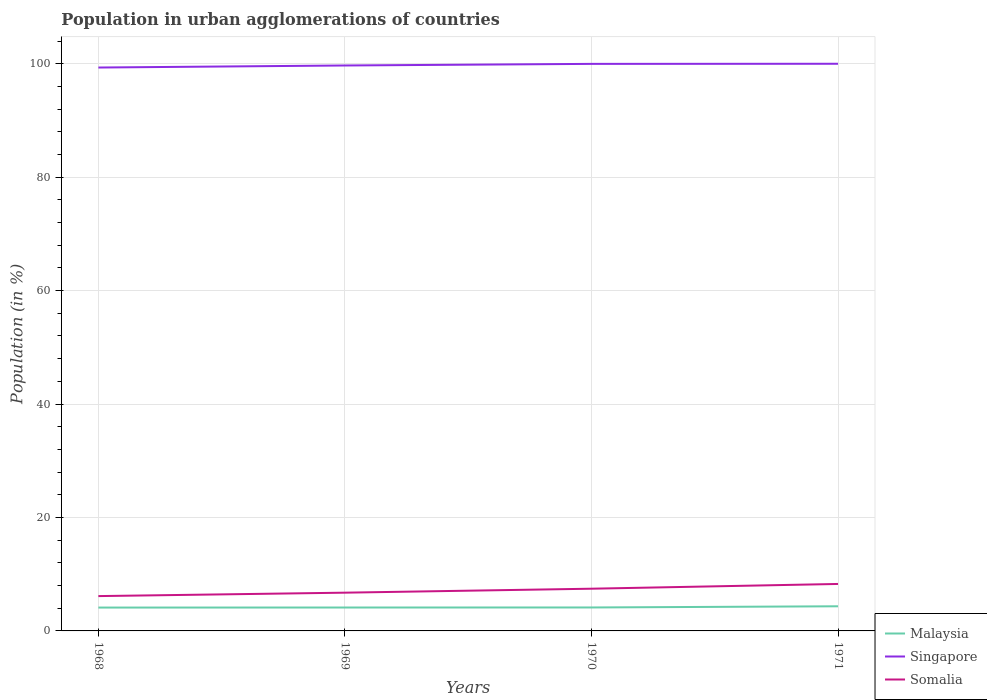How many different coloured lines are there?
Your response must be concise. 3. Across all years, what is the maximum percentage of population in urban agglomerations in Malaysia?
Give a very brief answer. 4.12. In which year was the percentage of population in urban agglomerations in Somalia maximum?
Offer a terse response. 1968. What is the total percentage of population in urban agglomerations in Somalia in the graph?
Offer a terse response. -0.84. What is the difference between the highest and the second highest percentage of population in urban agglomerations in Malaysia?
Your answer should be very brief. 0.23. What is the difference between the highest and the lowest percentage of population in urban agglomerations in Singapore?
Offer a very short reply. 2. How many lines are there?
Keep it short and to the point. 3. How many years are there in the graph?
Make the answer very short. 4. Are the values on the major ticks of Y-axis written in scientific E-notation?
Your response must be concise. No. How many legend labels are there?
Ensure brevity in your answer.  3. What is the title of the graph?
Provide a short and direct response. Population in urban agglomerations of countries. What is the Population (in %) in Malaysia in 1968?
Your response must be concise. 4.12. What is the Population (in %) of Singapore in 1968?
Your answer should be very brief. 99.34. What is the Population (in %) of Somalia in 1968?
Provide a short and direct response. 6.14. What is the Population (in %) of Malaysia in 1969?
Provide a short and direct response. 4.13. What is the Population (in %) of Singapore in 1969?
Ensure brevity in your answer.  99.7. What is the Population (in %) of Somalia in 1969?
Your answer should be very brief. 6.74. What is the Population (in %) in Malaysia in 1970?
Your answer should be very brief. 4.14. What is the Population (in %) in Singapore in 1970?
Provide a succinct answer. 99.98. What is the Population (in %) of Somalia in 1970?
Provide a succinct answer. 7.44. What is the Population (in %) in Malaysia in 1971?
Provide a short and direct response. 4.34. What is the Population (in %) in Singapore in 1971?
Offer a terse response. 100. What is the Population (in %) of Somalia in 1971?
Offer a very short reply. 8.28. Across all years, what is the maximum Population (in %) in Malaysia?
Provide a short and direct response. 4.34. Across all years, what is the maximum Population (in %) of Singapore?
Offer a terse response. 100. Across all years, what is the maximum Population (in %) in Somalia?
Offer a very short reply. 8.28. Across all years, what is the minimum Population (in %) of Malaysia?
Provide a short and direct response. 4.12. Across all years, what is the minimum Population (in %) in Singapore?
Your answer should be compact. 99.34. Across all years, what is the minimum Population (in %) of Somalia?
Offer a very short reply. 6.14. What is the total Population (in %) of Malaysia in the graph?
Your answer should be compact. 16.72. What is the total Population (in %) of Singapore in the graph?
Your response must be concise. 399.01. What is the total Population (in %) of Somalia in the graph?
Provide a succinct answer. 28.61. What is the difference between the Population (in %) in Malaysia in 1968 and that in 1969?
Your answer should be compact. -0.01. What is the difference between the Population (in %) of Singapore in 1968 and that in 1969?
Offer a terse response. -0.36. What is the difference between the Population (in %) in Somalia in 1968 and that in 1969?
Give a very brief answer. -0.6. What is the difference between the Population (in %) in Malaysia in 1968 and that in 1970?
Provide a short and direct response. -0.02. What is the difference between the Population (in %) of Singapore in 1968 and that in 1970?
Ensure brevity in your answer.  -0.64. What is the difference between the Population (in %) in Somalia in 1968 and that in 1970?
Offer a terse response. -1.3. What is the difference between the Population (in %) in Malaysia in 1968 and that in 1971?
Your answer should be compact. -0.23. What is the difference between the Population (in %) of Singapore in 1968 and that in 1971?
Provide a short and direct response. -0.66. What is the difference between the Population (in %) in Somalia in 1968 and that in 1971?
Offer a very short reply. -2.14. What is the difference between the Population (in %) of Malaysia in 1969 and that in 1970?
Offer a very short reply. -0.01. What is the difference between the Population (in %) of Singapore in 1969 and that in 1970?
Keep it short and to the point. -0.28. What is the difference between the Population (in %) of Somalia in 1969 and that in 1970?
Your answer should be very brief. -0.7. What is the difference between the Population (in %) of Malaysia in 1969 and that in 1971?
Offer a very short reply. -0.22. What is the difference between the Population (in %) in Singapore in 1969 and that in 1971?
Your answer should be compact. -0.3. What is the difference between the Population (in %) of Somalia in 1969 and that in 1971?
Ensure brevity in your answer.  -1.54. What is the difference between the Population (in %) of Malaysia in 1970 and that in 1971?
Provide a short and direct response. -0.21. What is the difference between the Population (in %) in Singapore in 1970 and that in 1971?
Ensure brevity in your answer.  -0.02. What is the difference between the Population (in %) in Somalia in 1970 and that in 1971?
Provide a short and direct response. -0.84. What is the difference between the Population (in %) in Malaysia in 1968 and the Population (in %) in Singapore in 1969?
Your answer should be compact. -95.58. What is the difference between the Population (in %) of Malaysia in 1968 and the Population (in %) of Somalia in 1969?
Offer a very short reply. -2.63. What is the difference between the Population (in %) in Singapore in 1968 and the Population (in %) in Somalia in 1969?
Your answer should be very brief. 92.59. What is the difference between the Population (in %) in Malaysia in 1968 and the Population (in %) in Singapore in 1970?
Provide a short and direct response. -95.86. What is the difference between the Population (in %) in Malaysia in 1968 and the Population (in %) in Somalia in 1970?
Make the answer very short. -3.32. What is the difference between the Population (in %) of Singapore in 1968 and the Population (in %) of Somalia in 1970?
Your answer should be very brief. 91.89. What is the difference between the Population (in %) of Malaysia in 1968 and the Population (in %) of Singapore in 1971?
Give a very brief answer. -95.88. What is the difference between the Population (in %) of Malaysia in 1968 and the Population (in %) of Somalia in 1971?
Your response must be concise. -4.16. What is the difference between the Population (in %) of Singapore in 1968 and the Population (in %) of Somalia in 1971?
Provide a short and direct response. 91.06. What is the difference between the Population (in %) of Malaysia in 1969 and the Population (in %) of Singapore in 1970?
Make the answer very short. -95.85. What is the difference between the Population (in %) in Malaysia in 1969 and the Population (in %) in Somalia in 1970?
Ensure brevity in your answer.  -3.32. What is the difference between the Population (in %) of Singapore in 1969 and the Population (in %) of Somalia in 1970?
Offer a terse response. 92.25. What is the difference between the Population (in %) of Malaysia in 1969 and the Population (in %) of Singapore in 1971?
Your response must be concise. -95.87. What is the difference between the Population (in %) of Malaysia in 1969 and the Population (in %) of Somalia in 1971?
Make the answer very short. -4.15. What is the difference between the Population (in %) of Singapore in 1969 and the Population (in %) of Somalia in 1971?
Give a very brief answer. 91.41. What is the difference between the Population (in %) of Malaysia in 1970 and the Population (in %) of Singapore in 1971?
Offer a very short reply. -95.86. What is the difference between the Population (in %) of Malaysia in 1970 and the Population (in %) of Somalia in 1971?
Keep it short and to the point. -4.14. What is the difference between the Population (in %) in Singapore in 1970 and the Population (in %) in Somalia in 1971?
Offer a very short reply. 91.7. What is the average Population (in %) of Malaysia per year?
Offer a very short reply. 4.18. What is the average Population (in %) in Singapore per year?
Make the answer very short. 99.75. What is the average Population (in %) in Somalia per year?
Offer a very short reply. 7.15. In the year 1968, what is the difference between the Population (in %) in Malaysia and Population (in %) in Singapore?
Offer a terse response. -95.22. In the year 1968, what is the difference between the Population (in %) in Malaysia and Population (in %) in Somalia?
Your response must be concise. -2.02. In the year 1968, what is the difference between the Population (in %) in Singapore and Population (in %) in Somalia?
Offer a very short reply. 93.19. In the year 1969, what is the difference between the Population (in %) of Malaysia and Population (in %) of Singapore?
Provide a succinct answer. -95.57. In the year 1969, what is the difference between the Population (in %) in Malaysia and Population (in %) in Somalia?
Your answer should be compact. -2.62. In the year 1969, what is the difference between the Population (in %) of Singapore and Population (in %) of Somalia?
Ensure brevity in your answer.  92.95. In the year 1970, what is the difference between the Population (in %) of Malaysia and Population (in %) of Singapore?
Give a very brief answer. -95.84. In the year 1970, what is the difference between the Population (in %) of Malaysia and Population (in %) of Somalia?
Make the answer very short. -3.31. In the year 1970, what is the difference between the Population (in %) of Singapore and Population (in %) of Somalia?
Offer a very short reply. 92.54. In the year 1971, what is the difference between the Population (in %) of Malaysia and Population (in %) of Singapore?
Give a very brief answer. -95.65. In the year 1971, what is the difference between the Population (in %) of Malaysia and Population (in %) of Somalia?
Offer a terse response. -3.94. In the year 1971, what is the difference between the Population (in %) of Singapore and Population (in %) of Somalia?
Give a very brief answer. 91.72. What is the ratio of the Population (in %) in Singapore in 1968 to that in 1969?
Ensure brevity in your answer.  1. What is the ratio of the Population (in %) of Somalia in 1968 to that in 1969?
Provide a succinct answer. 0.91. What is the ratio of the Population (in %) in Malaysia in 1968 to that in 1970?
Offer a terse response. 1. What is the ratio of the Population (in %) of Somalia in 1968 to that in 1970?
Your answer should be compact. 0.83. What is the ratio of the Population (in %) in Malaysia in 1968 to that in 1971?
Offer a terse response. 0.95. What is the ratio of the Population (in %) of Singapore in 1968 to that in 1971?
Offer a terse response. 0.99. What is the ratio of the Population (in %) in Somalia in 1968 to that in 1971?
Provide a succinct answer. 0.74. What is the ratio of the Population (in %) in Somalia in 1969 to that in 1970?
Ensure brevity in your answer.  0.91. What is the ratio of the Population (in %) of Malaysia in 1969 to that in 1971?
Your answer should be compact. 0.95. What is the ratio of the Population (in %) in Singapore in 1969 to that in 1971?
Make the answer very short. 1. What is the ratio of the Population (in %) in Somalia in 1969 to that in 1971?
Provide a short and direct response. 0.81. What is the ratio of the Population (in %) of Malaysia in 1970 to that in 1971?
Your answer should be very brief. 0.95. What is the ratio of the Population (in %) of Singapore in 1970 to that in 1971?
Provide a short and direct response. 1. What is the ratio of the Population (in %) in Somalia in 1970 to that in 1971?
Your answer should be compact. 0.9. What is the difference between the highest and the second highest Population (in %) in Malaysia?
Your response must be concise. 0.21. What is the difference between the highest and the second highest Population (in %) of Singapore?
Your answer should be compact. 0.02. What is the difference between the highest and the second highest Population (in %) in Somalia?
Offer a terse response. 0.84. What is the difference between the highest and the lowest Population (in %) in Malaysia?
Your answer should be compact. 0.23. What is the difference between the highest and the lowest Population (in %) in Singapore?
Give a very brief answer. 0.66. What is the difference between the highest and the lowest Population (in %) of Somalia?
Keep it short and to the point. 2.14. 